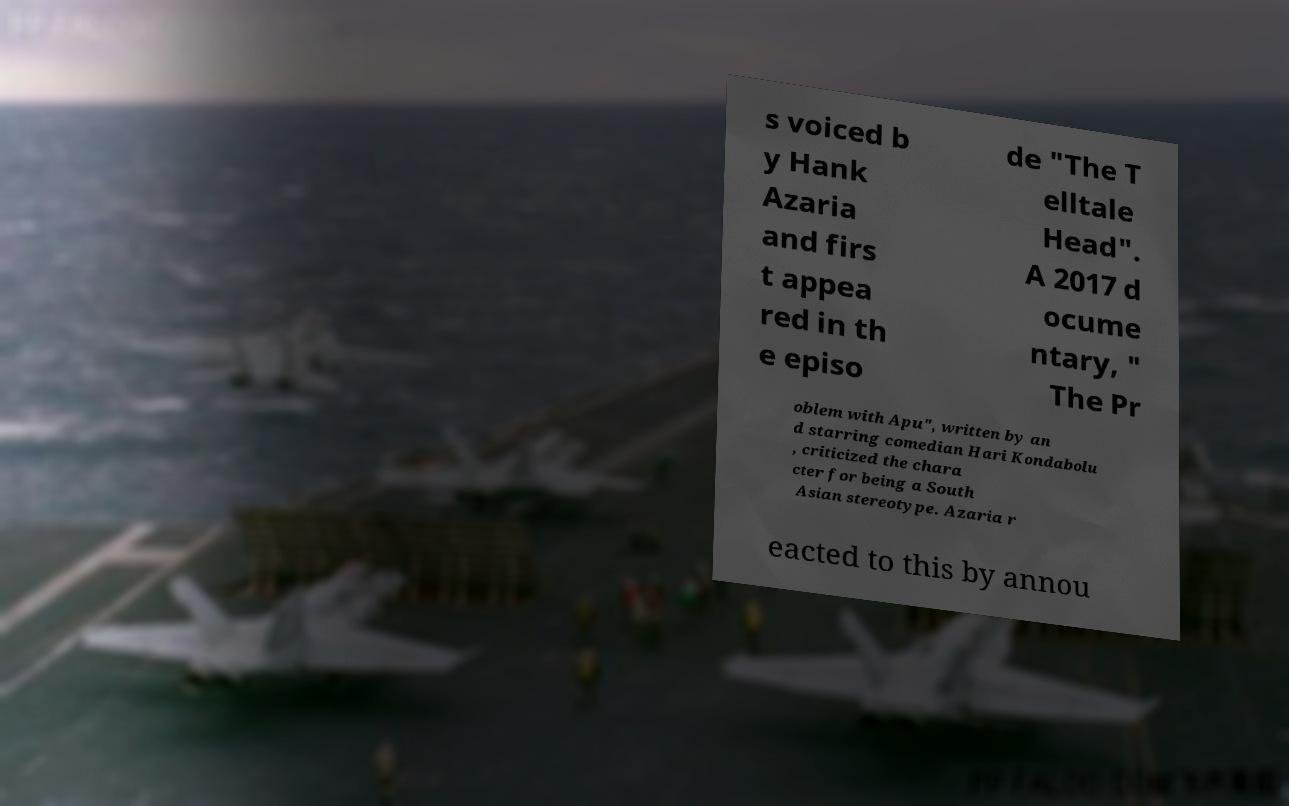Can you read and provide the text displayed in the image?This photo seems to have some interesting text. Can you extract and type it out for me? s voiced b y Hank Azaria and firs t appea red in th e episo de "The T elltale Head". A 2017 d ocume ntary, " The Pr oblem with Apu", written by an d starring comedian Hari Kondabolu , criticized the chara cter for being a South Asian stereotype. Azaria r eacted to this by annou 